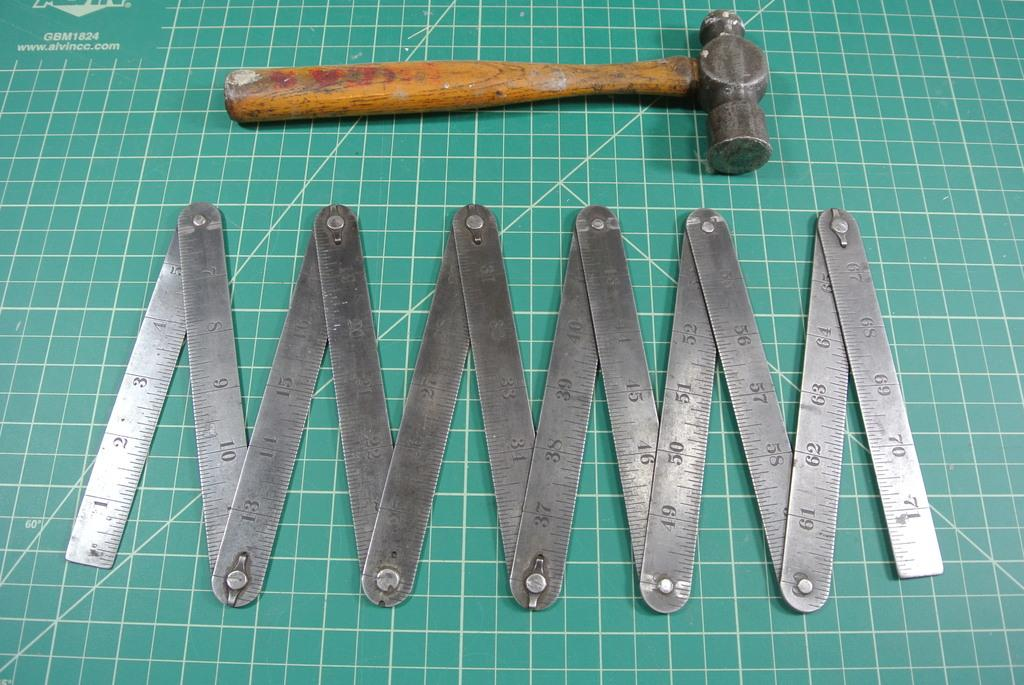Provide a one-sentence caption for the provided image. Tools are laid out on a green mat, which is labelled GBM1824 and has the website ww.alvincc.com printed on it. 